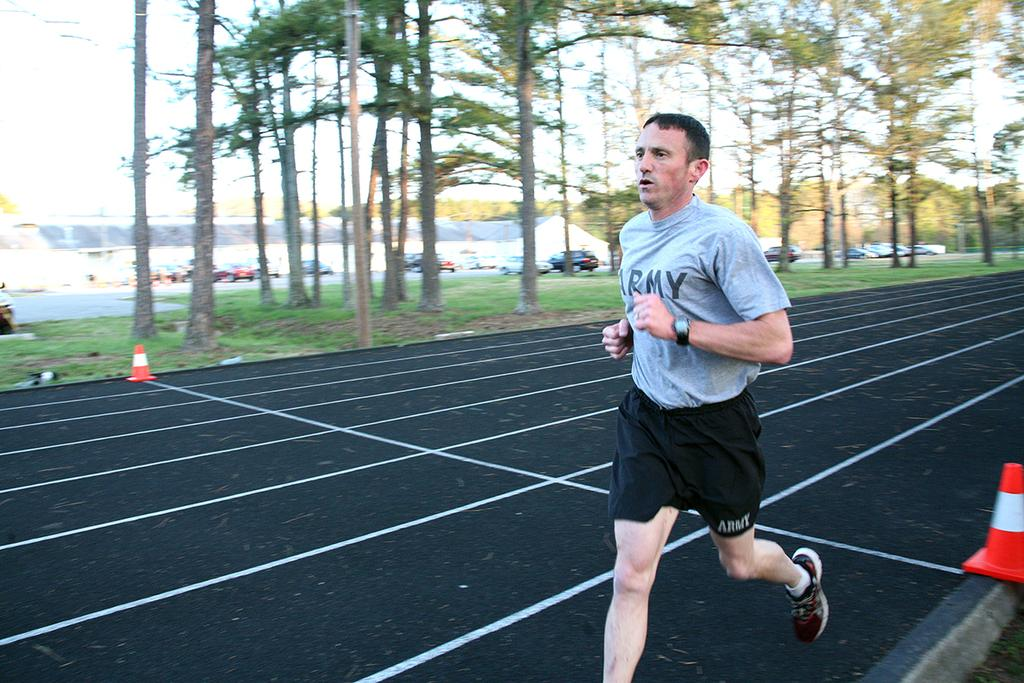<image>
Provide a brief description of the given image. A man wearing a grey Army t shirt is running on a black track. 